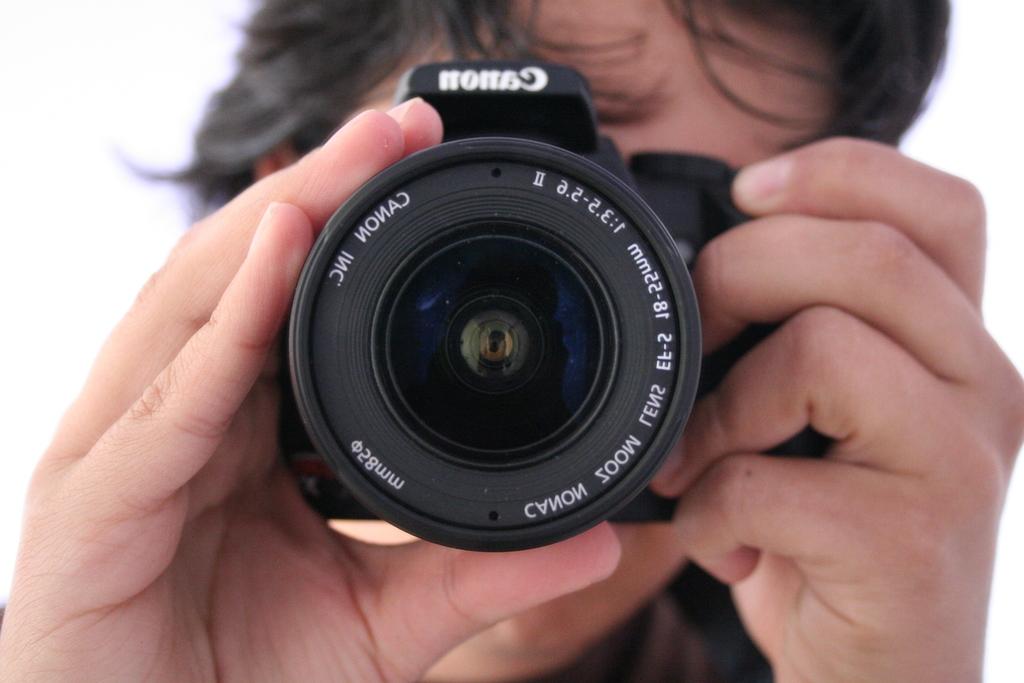What size lens is being used?
Offer a very short reply. 28mm. What brand of camera are we looking at?
Your answer should be very brief. Canon. 